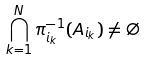<formula> <loc_0><loc_0><loc_500><loc_500>\bigcap _ { k = 1 } ^ { N } \pi _ { i _ { k } } ^ { - 1 } ( A _ { i _ { k } } ) \ne \emptyset</formula> 